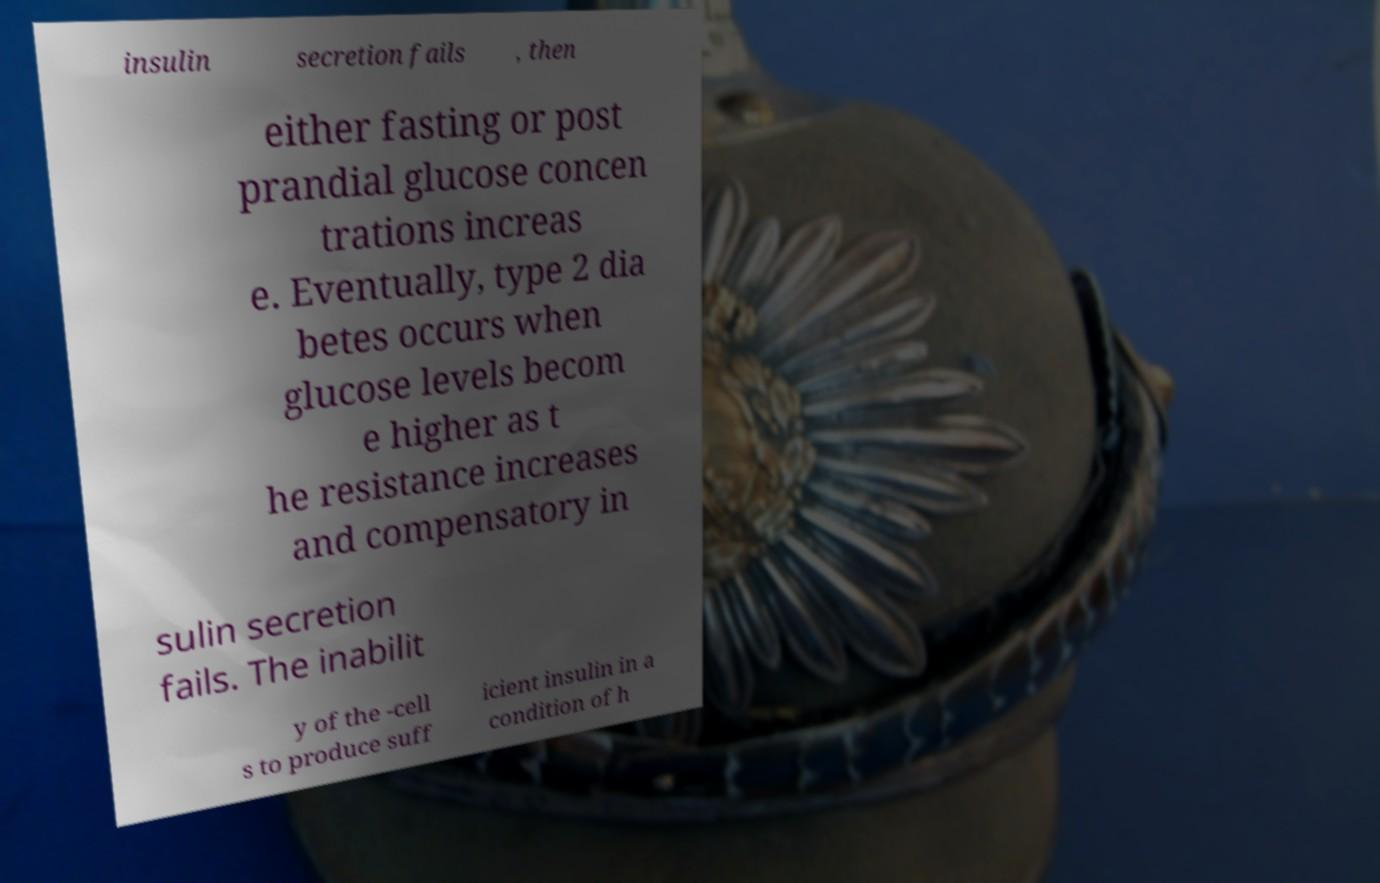There's text embedded in this image that I need extracted. Can you transcribe it verbatim? insulin secretion fails , then either fasting or post prandial glucose concen trations increas e. Eventually, type 2 dia betes occurs when glucose levels becom e higher as t he resistance increases and compensatory in sulin secretion fails. The inabilit y of the -cell s to produce suff icient insulin in a condition of h 